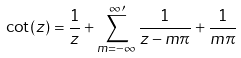Convert formula to latex. <formula><loc_0><loc_0><loc_500><loc_500>\cot ( z ) = \frac { 1 } { z } + \sum _ { m = - \infty } ^ { \infty \prime } \frac { 1 } { z - m \pi } + \frac { 1 } { m \pi }</formula> 